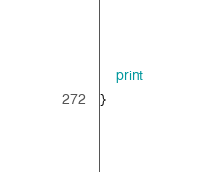<code> <loc_0><loc_0><loc_500><loc_500><_Awk_>	print
}
</code> 